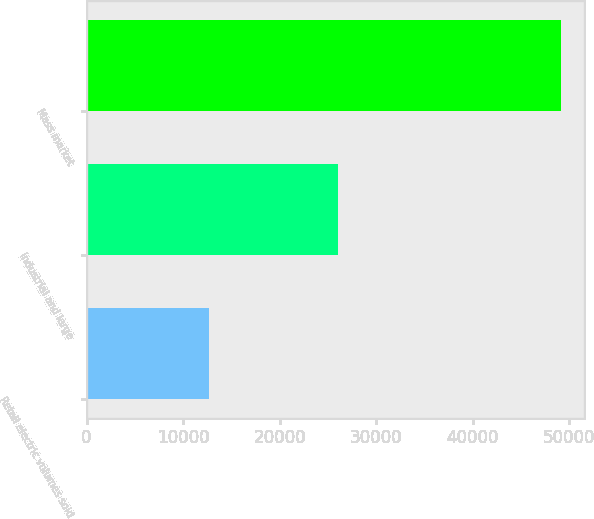<chart> <loc_0><loc_0><loc_500><loc_500><bar_chart><fcel>Retail electric volumes sold<fcel>Industrial and large<fcel>Mass market<nl><fcel>12723<fcel>26009<fcel>49094<nl></chart> 